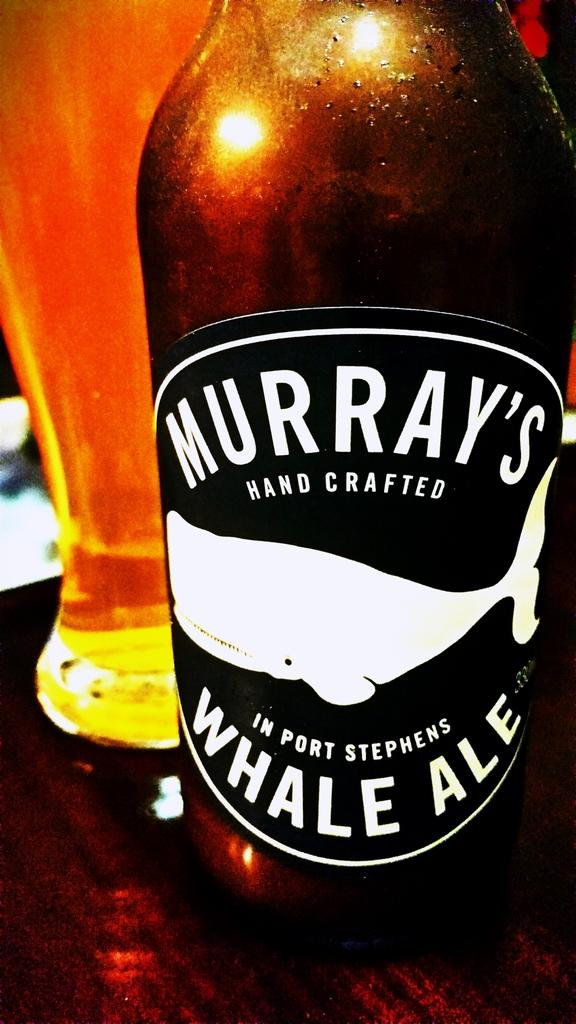Provide a one-sentence caption for the provided image. A bottle of Murray's Whale Ale sits in front of a glass filled with beer. 